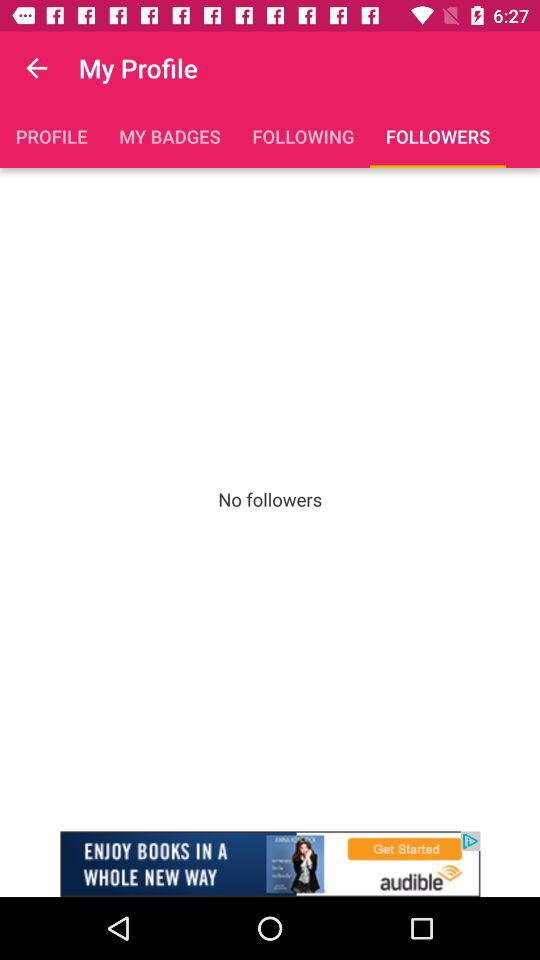Are there any followers? There are no followers. 